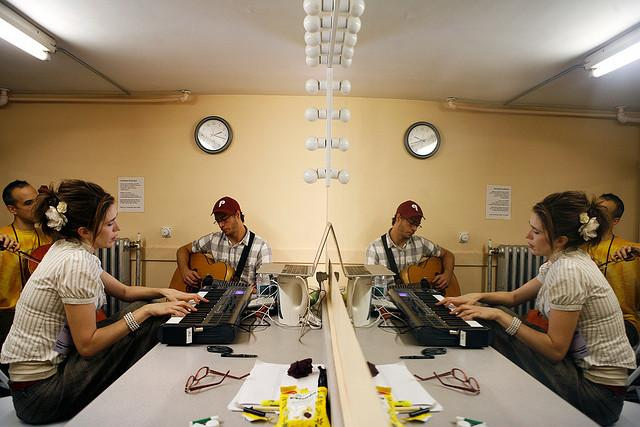At least how many musicians play different instruments here?

Choices:
A) two
B) eight
C) one
D) three three 